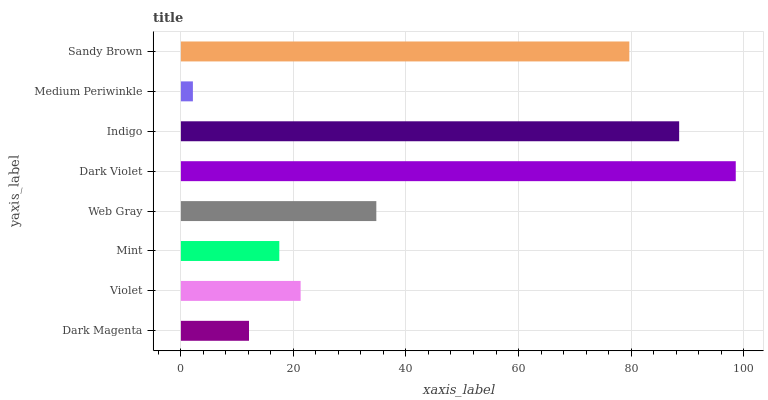Is Medium Periwinkle the minimum?
Answer yes or no. Yes. Is Dark Violet the maximum?
Answer yes or no. Yes. Is Violet the minimum?
Answer yes or no. No. Is Violet the maximum?
Answer yes or no. No. Is Violet greater than Dark Magenta?
Answer yes or no. Yes. Is Dark Magenta less than Violet?
Answer yes or no. Yes. Is Dark Magenta greater than Violet?
Answer yes or no. No. Is Violet less than Dark Magenta?
Answer yes or no. No. Is Web Gray the high median?
Answer yes or no. Yes. Is Violet the low median?
Answer yes or no. Yes. Is Mint the high median?
Answer yes or no. No. Is Dark Violet the low median?
Answer yes or no. No. 